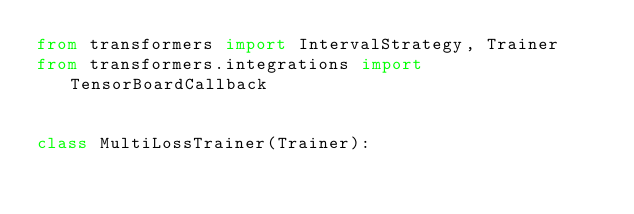Convert code to text. <code><loc_0><loc_0><loc_500><loc_500><_Python_>from transformers import IntervalStrategy, Trainer
from transformers.integrations import TensorBoardCallback


class MultiLossTrainer(Trainer):</code> 